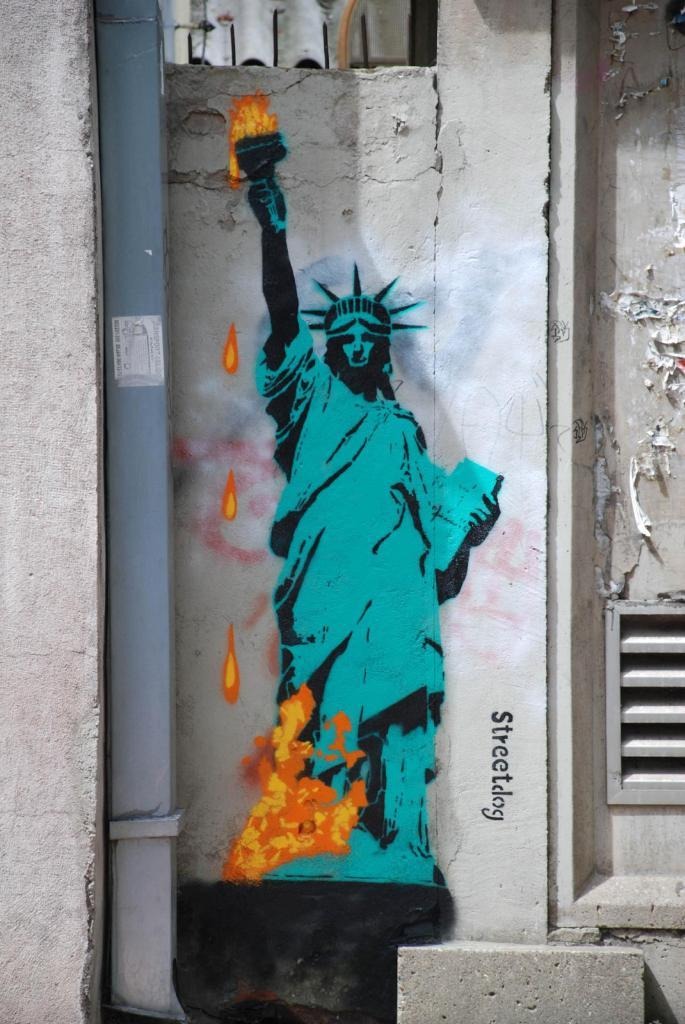What is the main subject in the center of the image? There is a painting on the wall in the center of the image. How much sugar is in the painting in the image? There is no sugar present in the painting or the image; it is a painting on a wall. 